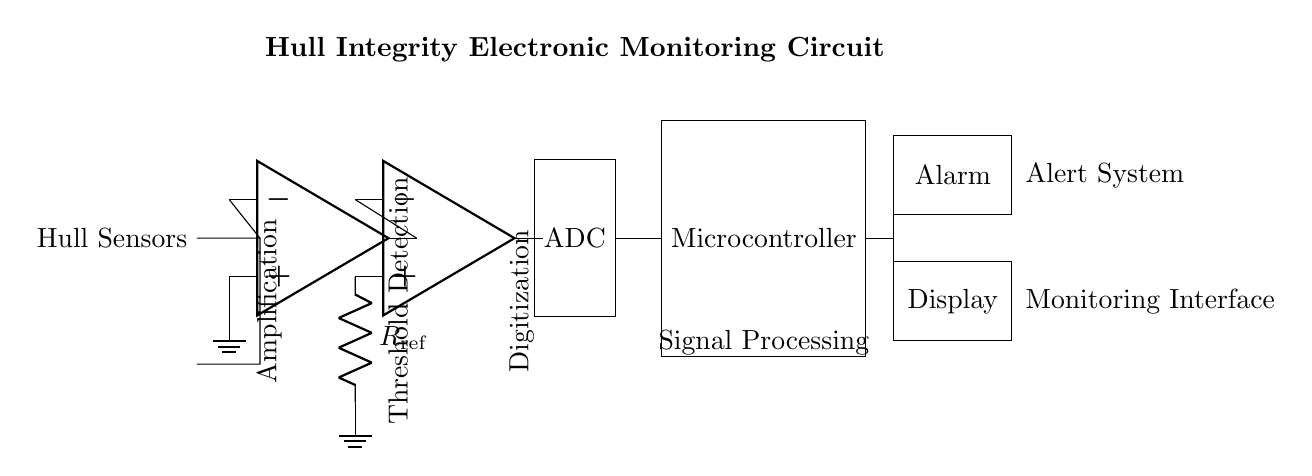What is the primary function of the op-amp in this circuit? The op-amp serves to amplify the voltage signal from the hull sensors, increasing the signal level for further processing. This is critical since hull sensors typically provide low-level signals.
Answer: Amplification What type of output does the ADC produce? The ADC converts the analog signals from the op-amp into digital signals, which the microcontroller can process. This is necessary for data analysis and alert generation.
Answer: Digital How many major components are present in the circuit? The circuit has six major components: hull sensors, an amplifier, a comparator, an ADC, a microcontroller, and alert systems (alarm and display).
Answer: Six What is the purpose of the R_ref resistor? The R_ref resistor in the comparator circuit sets a reference voltage level, which determines the threshold for signal detection from the op-amp output. If the amplified signal exceeds this reference level, the comparator will trigger a response.
Answer: Threshold detection Which component is responsible for alerting the user in case of hull integrity issues? The alarm component directly alerts the user when a hull integrity issue is detected, signaling a fault condition based on processed signals from the microcontroller.
Answer: Alarm What does the display component indicate? The display provides a visual interface to show the status of the hull integrity monitoring, allowing users to monitor conditions in real-time while the system operates.
Answer: Monitoring interface 